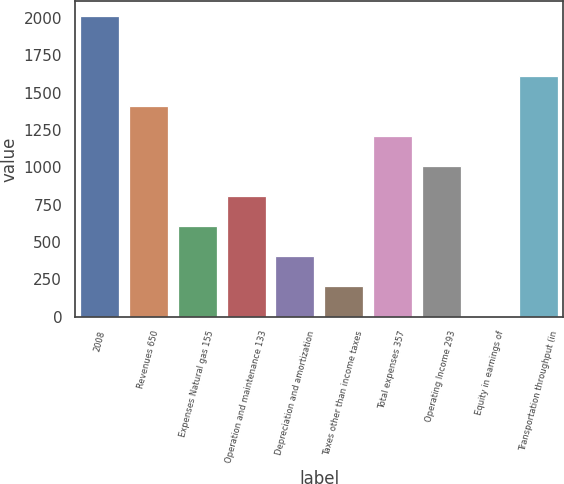Convert chart to OTSL. <chart><loc_0><loc_0><loc_500><loc_500><bar_chart><fcel>2008<fcel>Revenues 650<fcel>Expenses Natural gas 155<fcel>Operation and maintenance 133<fcel>Depreciation and amortization<fcel>Taxes other than income taxes<fcel>Total expenses 357<fcel>Operating Income 293<fcel>Equity in earnings of<fcel>Transportation throughput (in<nl><fcel>2009<fcel>1408.4<fcel>607.6<fcel>807.8<fcel>407.4<fcel>207.2<fcel>1208.2<fcel>1008<fcel>7<fcel>1608.6<nl></chart> 